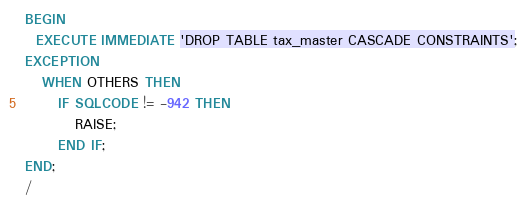<code> <loc_0><loc_0><loc_500><loc_500><_SQL_>BEGIN
  EXECUTE IMMEDIATE 'DROP TABLE tax_master CASCADE CONSTRAINTS';
EXCEPTION
   WHEN OTHERS THEN
      IF SQLCODE != -942 THEN
         RAISE;
      END IF;
END;
/</code> 